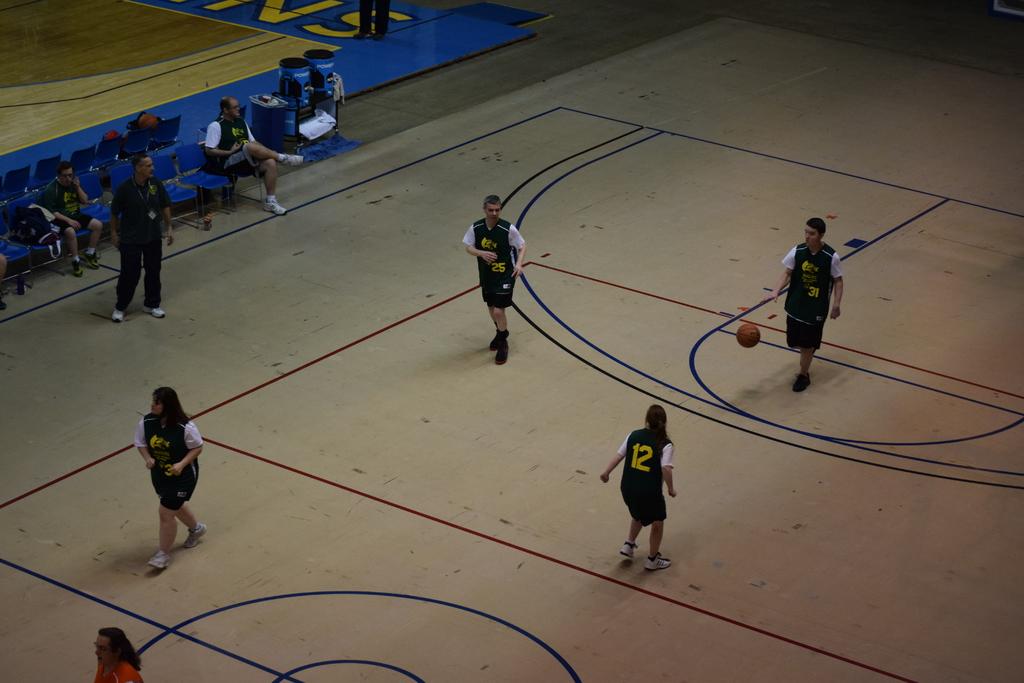What is the number on the jersey?
Your response must be concise. 12. 